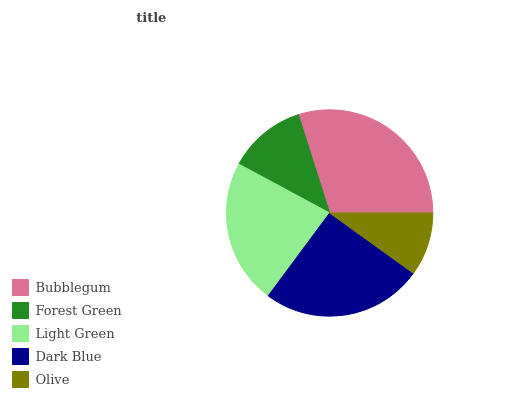Is Olive the minimum?
Answer yes or no. Yes. Is Bubblegum the maximum?
Answer yes or no. Yes. Is Forest Green the minimum?
Answer yes or no. No. Is Forest Green the maximum?
Answer yes or no. No. Is Bubblegum greater than Forest Green?
Answer yes or no. Yes. Is Forest Green less than Bubblegum?
Answer yes or no. Yes. Is Forest Green greater than Bubblegum?
Answer yes or no. No. Is Bubblegum less than Forest Green?
Answer yes or no. No. Is Light Green the high median?
Answer yes or no. Yes. Is Light Green the low median?
Answer yes or no. Yes. Is Olive the high median?
Answer yes or no. No. Is Bubblegum the low median?
Answer yes or no. No. 